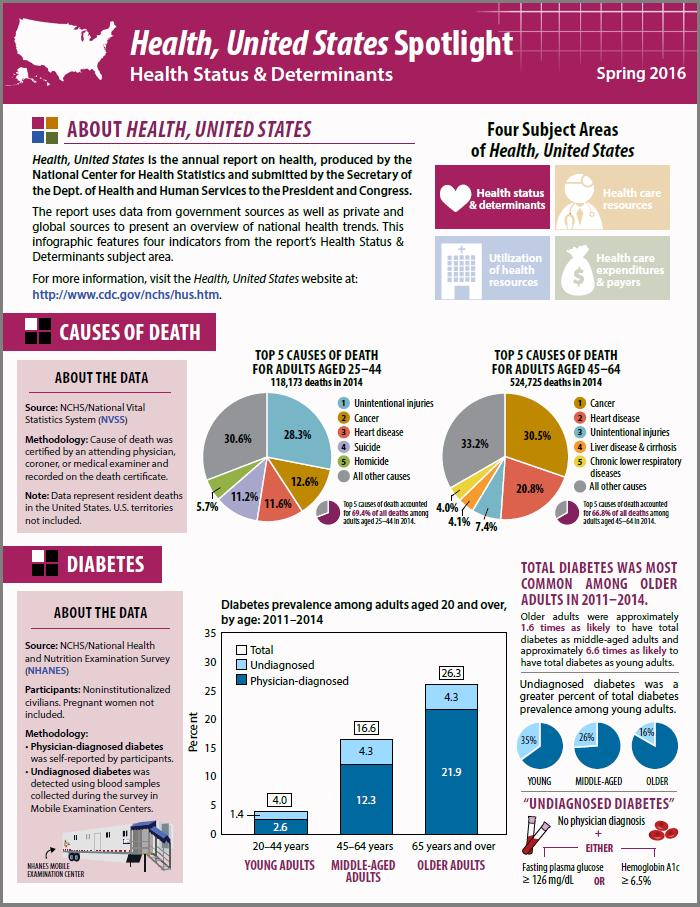Point out several critical features in this image. In the years 2011-2014, approximately 4.3% of middle-aged adults in the United States were undiagnosed with diabetes. According to a recent study, 24.2% of individuals aged 25-44 years old die from cancer and heart disease. In adults aged 45-64, cancer is the most common cause of death. According to the pie chart, among young adults, 35% of people had undiagnosed diabetes. 